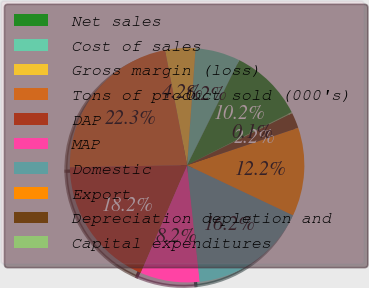<chart> <loc_0><loc_0><loc_500><loc_500><pie_chart><fcel>Net sales<fcel>Cost of sales<fcel>Gross margin (loss)<fcel>Tons of product sold (000's)<fcel>DAP<fcel>MAP<fcel>Domestic<fcel>Export<fcel>Depreciation depletion and<fcel>Capital expenditures<nl><fcel>10.2%<fcel>6.18%<fcel>4.17%<fcel>22.27%<fcel>18.25%<fcel>8.19%<fcel>16.24%<fcel>12.21%<fcel>2.15%<fcel>0.14%<nl></chart> 